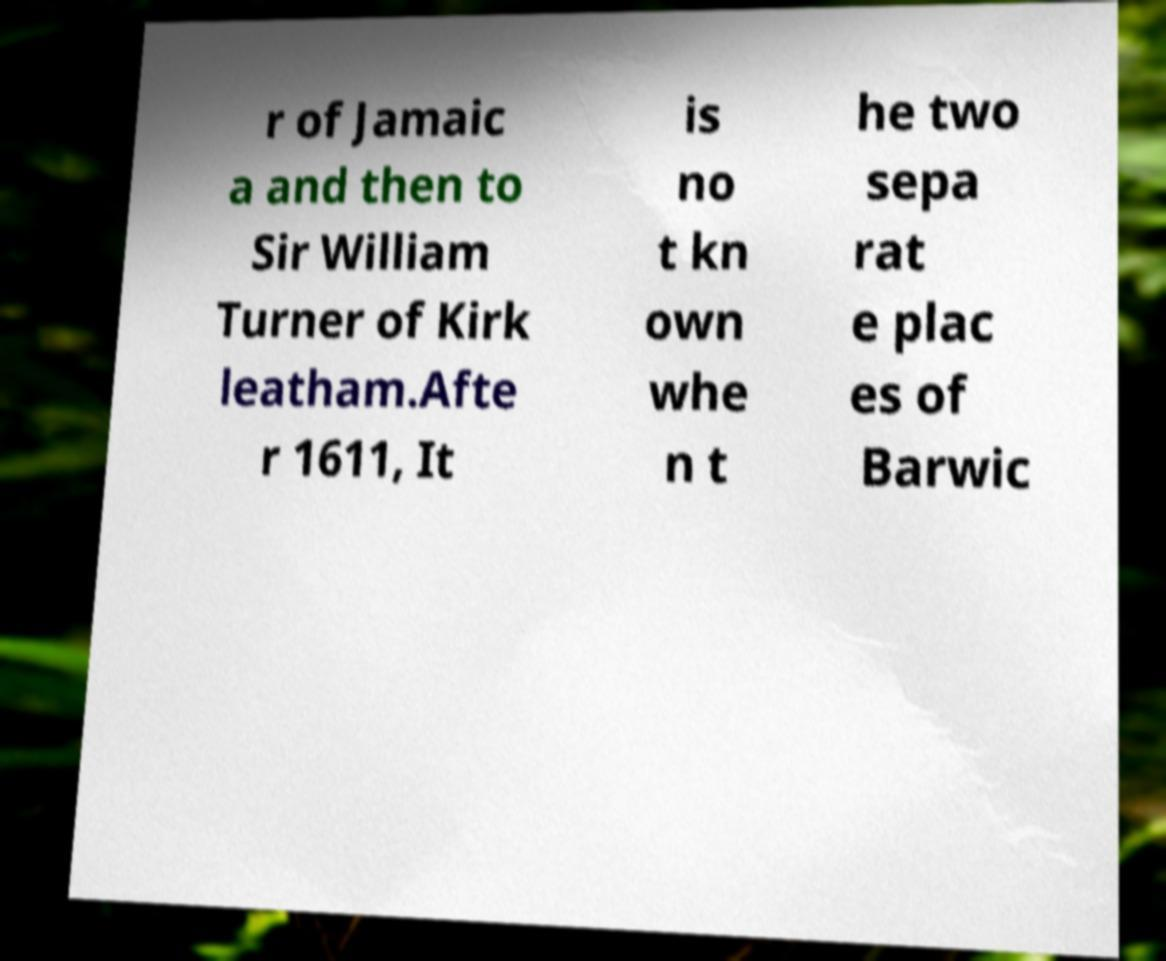Please read and relay the text visible in this image. What does it say? r of Jamaic a and then to Sir William Turner of Kirk leatham.Afte r 1611, It is no t kn own whe n t he two sepa rat e plac es of Barwic 